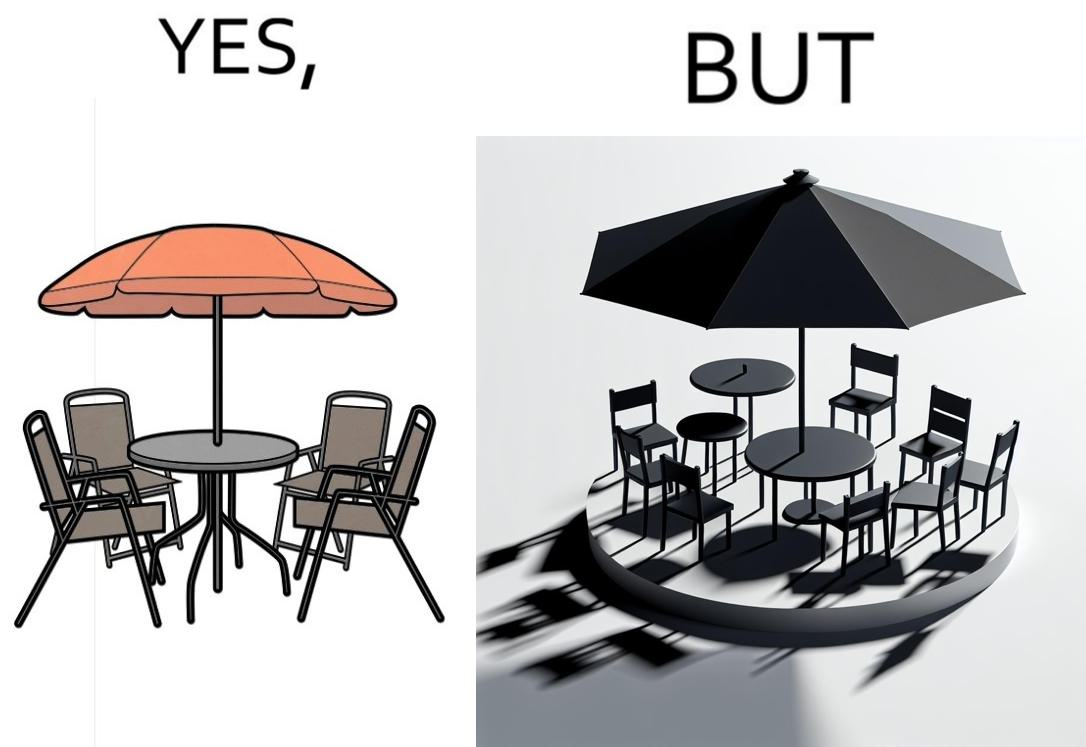Is this a satirical image? Yes, this image is satirical. 